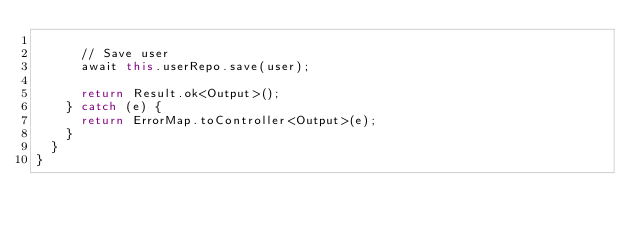Convert code to text. <code><loc_0><loc_0><loc_500><loc_500><_TypeScript_>
      // Save user
      await this.userRepo.save(user);

      return Result.ok<Output>();
    } catch (e) {
      return ErrorMap.toController<Output>(e);
    }
  }
}
</code> 